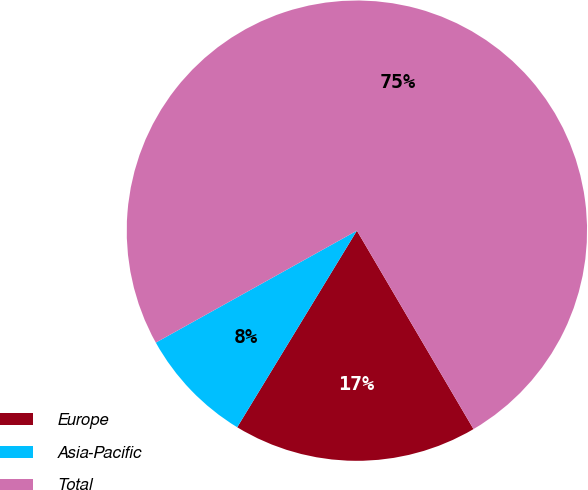<chart> <loc_0><loc_0><loc_500><loc_500><pie_chart><fcel>Europe<fcel>Asia-Pacific<fcel>Total<nl><fcel>17.16%<fcel>8.21%<fcel>74.63%<nl></chart> 